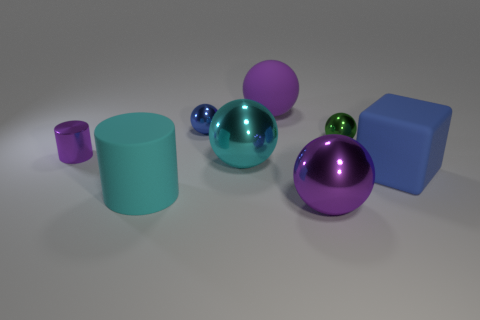Subtract all blue metallic balls. How many balls are left? 4 Subtract all purple cylinders. How many cylinders are left? 1 Subtract 0 brown blocks. How many objects are left? 8 Subtract all cylinders. How many objects are left? 6 Subtract 1 blocks. How many blocks are left? 0 Subtract all cyan blocks. Subtract all cyan cylinders. How many blocks are left? 1 Subtract all yellow blocks. How many purple cylinders are left? 1 Subtract all shiny blocks. Subtract all blue rubber cubes. How many objects are left? 7 Add 7 big rubber objects. How many big rubber objects are left? 10 Add 8 large blue matte cubes. How many large blue matte cubes exist? 9 